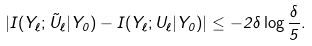Convert formula to latex. <formula><loc_0><loc_0><loc_500><loc_500>| I ( Y _ { \ell } ; \tilde { U } _ { \ell } | Y _ { 0 } ) - I ( Y _ { \ell } ; U _ { \ell } | Y _ { 0 } ) | \leq - 2 \delta \log \frac { \delta } { 5 } .</formula> 